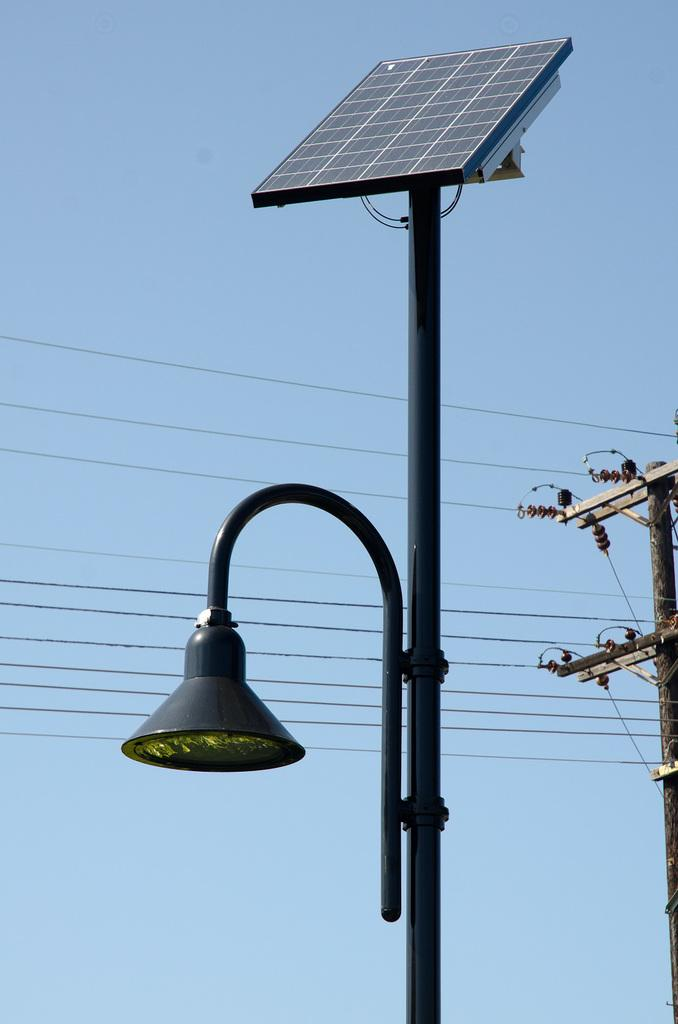What is the main object in the center of the image? There is a pole with a solar panel in the center of the image. What other type of pole can be seen in the image? There is an electric pole in the image. What connects the two poles in the image? There are wires in the image. What can be seen in the background of the image? The sky is visible in the background of the image. What type of scissors are being used to cut the wires in the image? There are no scissors present in the image, and the wires are not being cut. What educational institution can be seen in the image? There is no educational institution present in the image. 